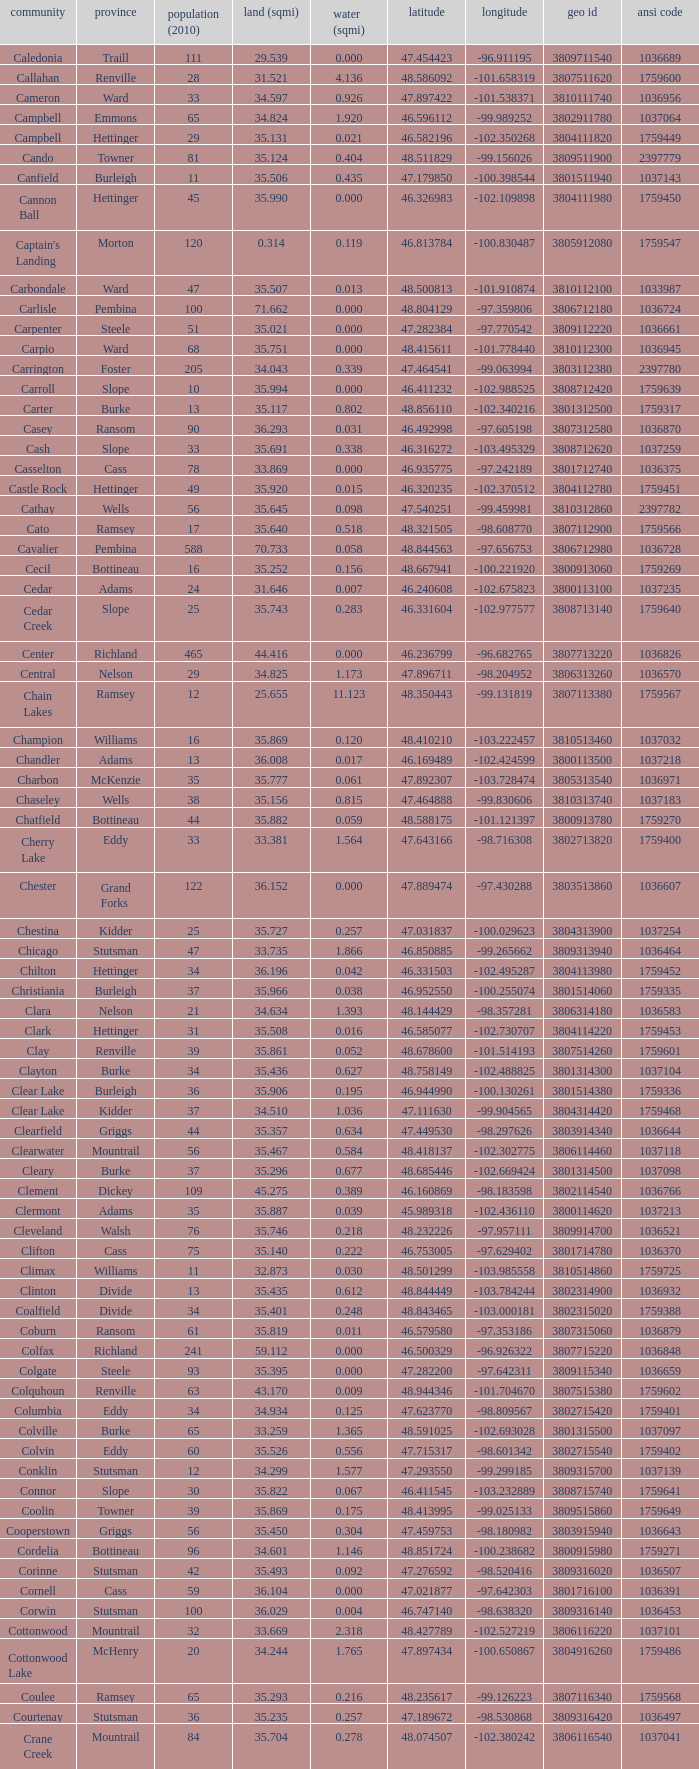What was the municipality with a geo id of 3807116660? Creel. 